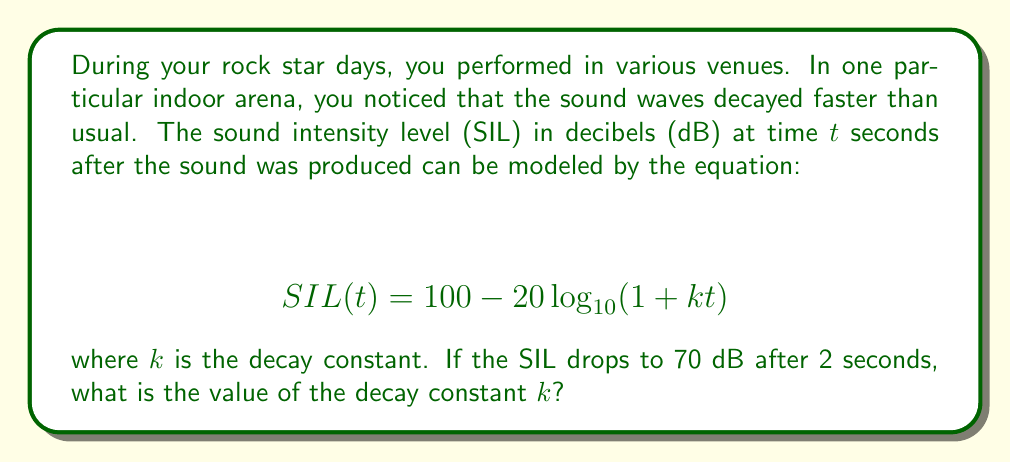Provide a solution to this math problem. To solve this problem, we need to follow these steps:

1) We know that after 2 seconds, the SIL is 70 dB. Let's substitute these values into the equation:

   $$ 70 = 100 - 20\log_{10}(1 + k(2)) $$

2) Simplify the right side of the equation:

   $$ 70 = 100 - 20\log_{10}(1 + 2k) $$

3) Subtract 100 from both sides:

   $$ -30 = -20\log_{10}(1 + 2k) $$

4) Divide both sides by -20:

   $$ 1.5 = \log_{10}(1 + 2k) $$

5) Apply $10^x$ to both sides:

   $$ 10^{1.5} = 1 + 2k $$

6) Calculate $10^{1.5}$:

   $$ 31.6228 \approx 1 + 2k $$

7) Subtract 1 from both sides:

   $$ 30.6228 \approx 2k $$

8) Divide both sides by 2:

   $$ 15.3114 \approx k $$

Therefore, the decay constant $k$ is approximately 15.3114.
Answer: $k \approx 15.3114$ 